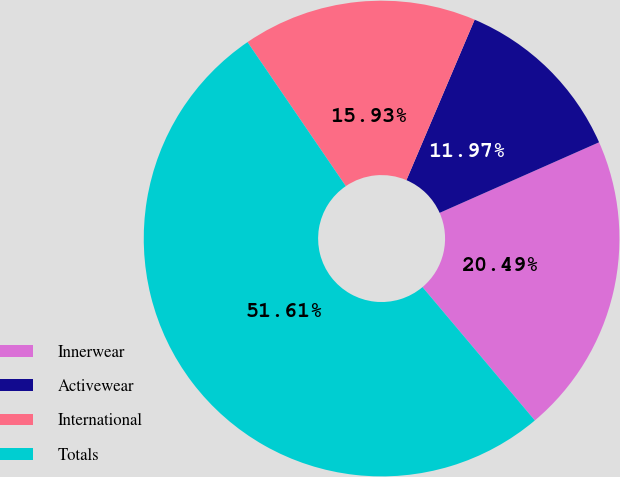<chart> <loc_0><loc_0><loc_500><loc_500><pie_chart><fcel>Innerwear<fcel>Activewear<fcel>International<fcel>Totals<nl><fcel>20.49%<fcel>11.97%<fcel>15.93%<fcel>51.61%<nl></chart> 